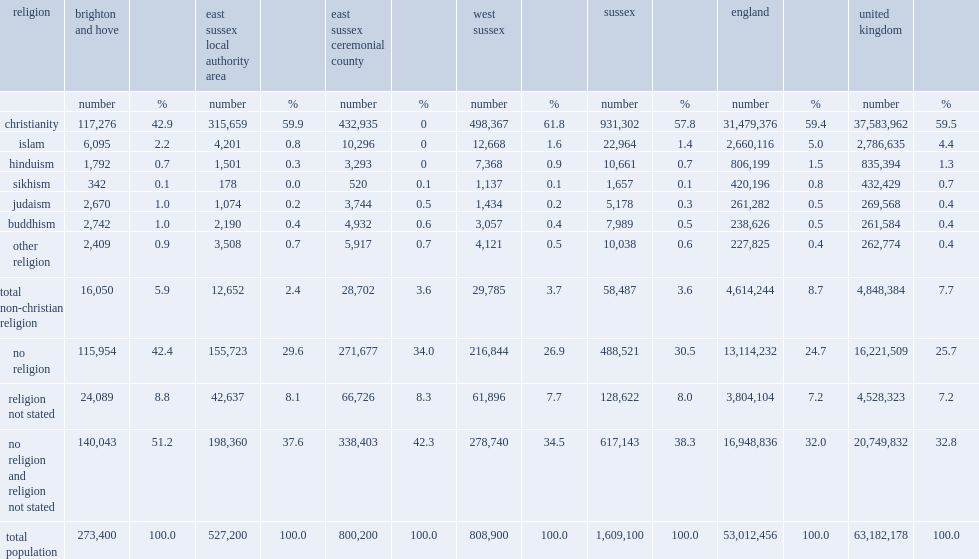What was the proportion of 'no religion' in brighton and hove? 42.4. 